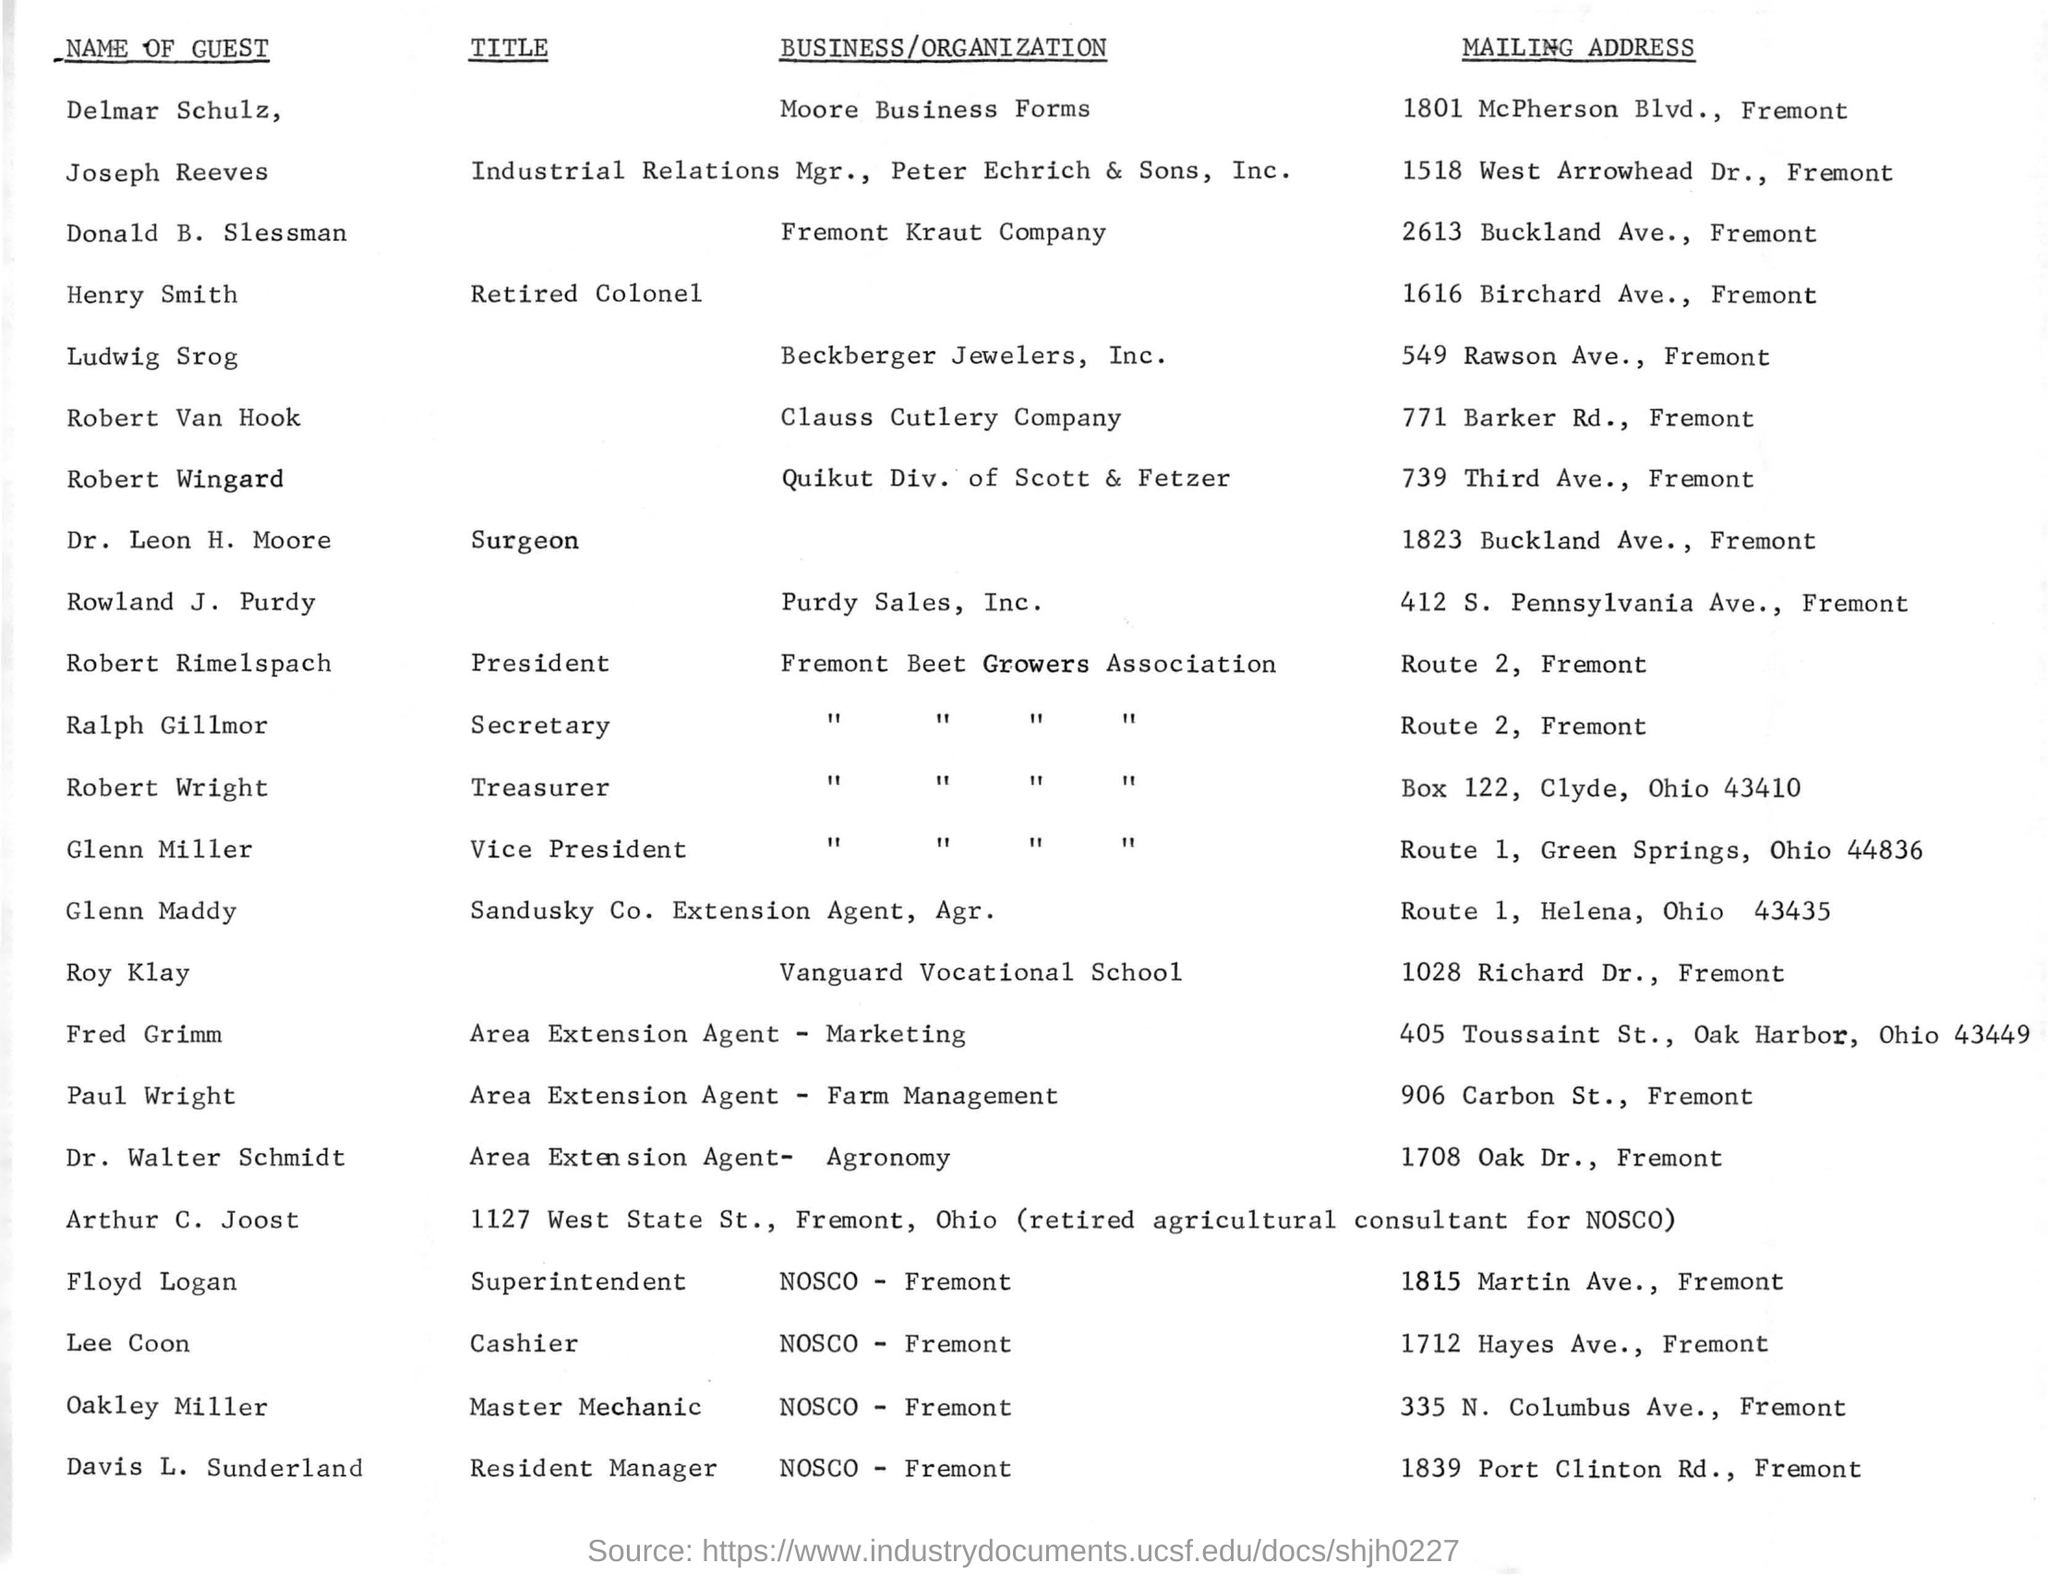What is the Mailing Address of Delmar Schulz?
Provide a short and direct response. 1801 McPherson Blvd., Fremont. What is the title of the Dr.Leon H. Moore ?
Give a very brief answer. Surgeon. What is the Mailing Address of Glenn Maddy ?
Give a very brief answer. Route 1, Helena, Ohio 43435. Who is the only cashier in this list?
Keep it short and to the point. Lee coon. 